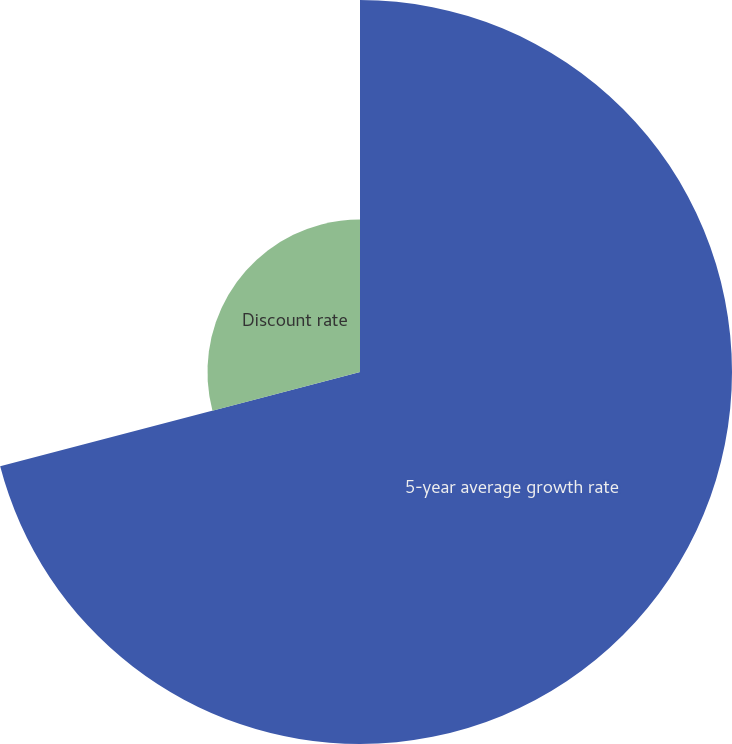Convert chart. <chart><loc_0><loc_0><loc_500><loc_500><pie_chart><fcel>5-year average growth rate<fcel>Discount rate<nl><fcel>70.92%<fcel>29.08%<nl></chart> 